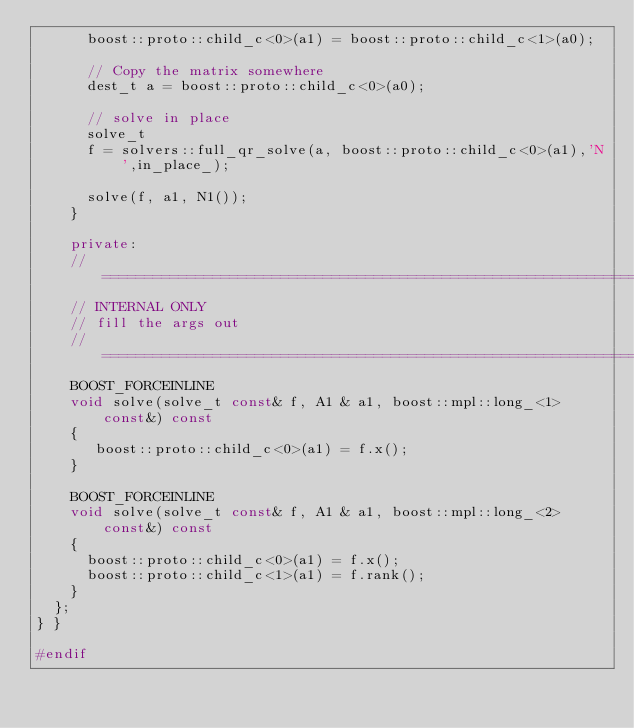<code> <loc_0><loc_0><loc_500><loc_500><_C++_>      boost::proto::child_c<0>(a1) = boost::proto::child_c<1>(a0);

      // Copy the matrix somewhere
      dest_t a = boost::proto::child_c<0>(a0);

      // solve in place
      solve_t
      f = solvers::full_qr_solve(a, boost::proto::child_c<0>(a1),'N',in_place_);

      solve(f, a1, N1());
    }

    private:
    //==========================================================================
    // INTERNAL ONLY
    // fill the args out
    //==========================================================================
    BOOST_FORCEINLINE
    void solve(solve_t const& f, A1 & a1, boost::mpl::long_<1> const&) const
    {
       boost::proto::child_c<0>(a1) = f.x();
    }

    BOOST_FORCEINLINE
    void solve(solve_t const& f, A1 & a1, boost::mpl::long_<2> const&) const
    {
      boost::proto::child_c<0>(a1) = f.x();
      boost::proto::child_c<1>(a1) = f.rank();
    }
  };
} }

#endif
</code> 